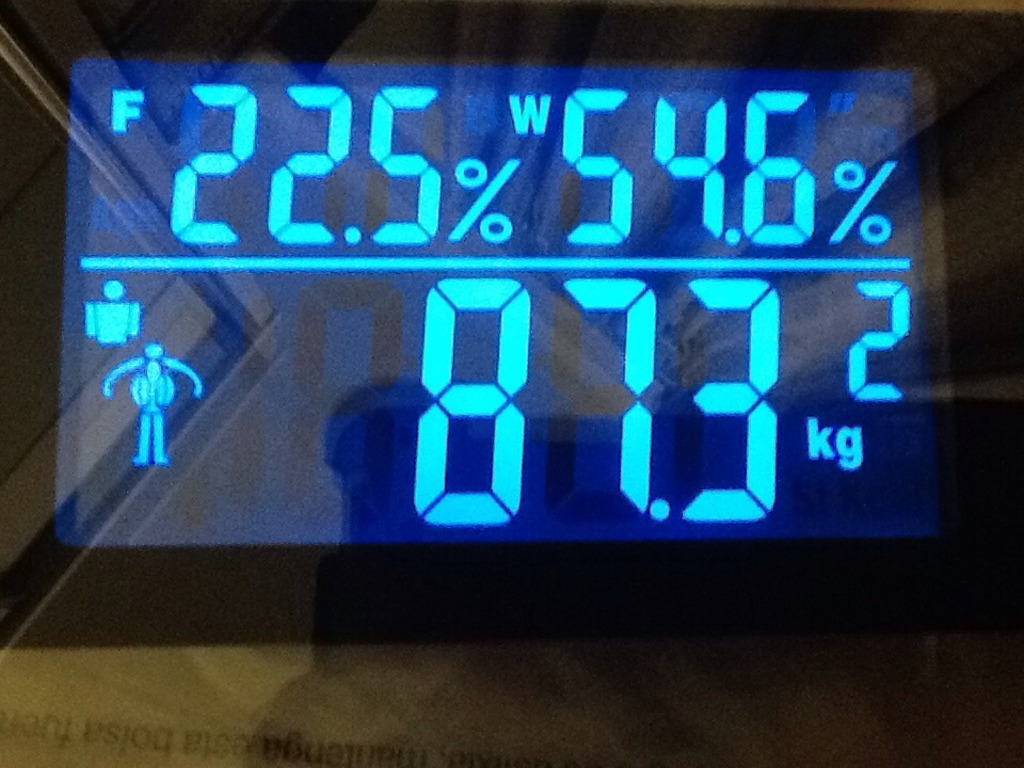Why might the scale use icons like the one with a shield? Icons like the one with a shield are often used to denote special modes or features. For instance, this icon could represent a sport mode that considers the altered physique needs of athletes, or a protective mode that calculates the ideal body metrics, accounting for protective gear or additional equipment weight. 